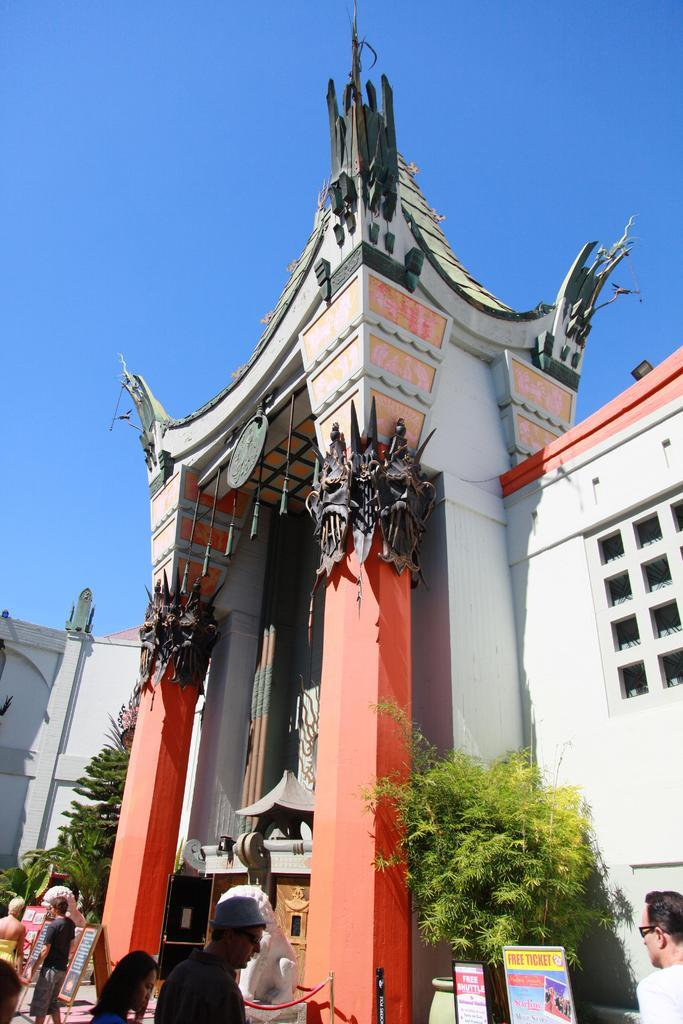Who or what can be seen in the image? There are people in the image. What is the background of the image? The people are standing in front of a tall building. Are there any other elements visible in the image? Yes, there are trees visible outside the building. What type of lamp is hanging from the tree in the image? There is no lamp hanging from a tree in the image; there are only people, a tall building, and trees visible. 